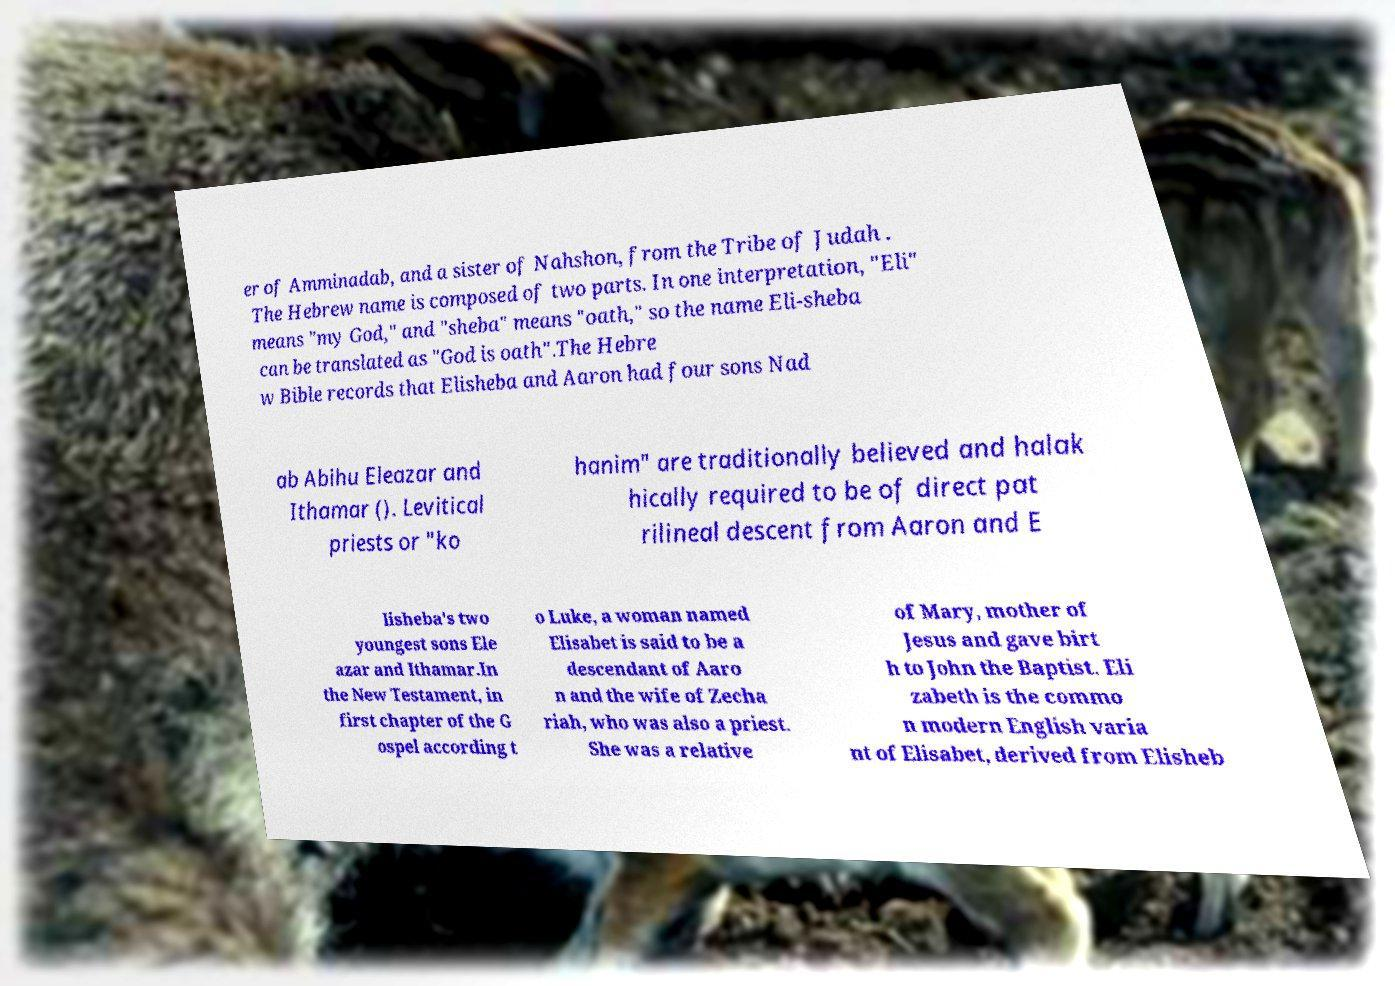For documentation purposes, I need the text within this image transcribed. Could you provide that? er of Amminadab, and a sister of Nahshon, from the Tribe of Judah . The Hebrew name is composed of two parts. In one interpretation, "Eli" means "my God," and "sheba" means "oath," so the name Eli-sheba can be translated as "God is oath".The Hebre w Bible records that Elisheba and Aaron had four sons Nad ab Abihu Eleazar and Ithamar (). Levitical priests or "ko hanim" are traditionally believed and halak hically required to be of direct pat rilineal descent from Aaron and E lisheba's two youngest sons Ele azar and Ithamar.In the New Testament, in first chapter of the G ospel according t o Luke, a woman named Elisabet is said to be a descendant of Aaro n and the wife of Zecha riah, who was also a priest. She was a relative of Mary, mother of Jesus and gave birt h to John the Baptist. Eli zabeth is the commo n modern English varia nt of Elisabet, derived from Elisheb 